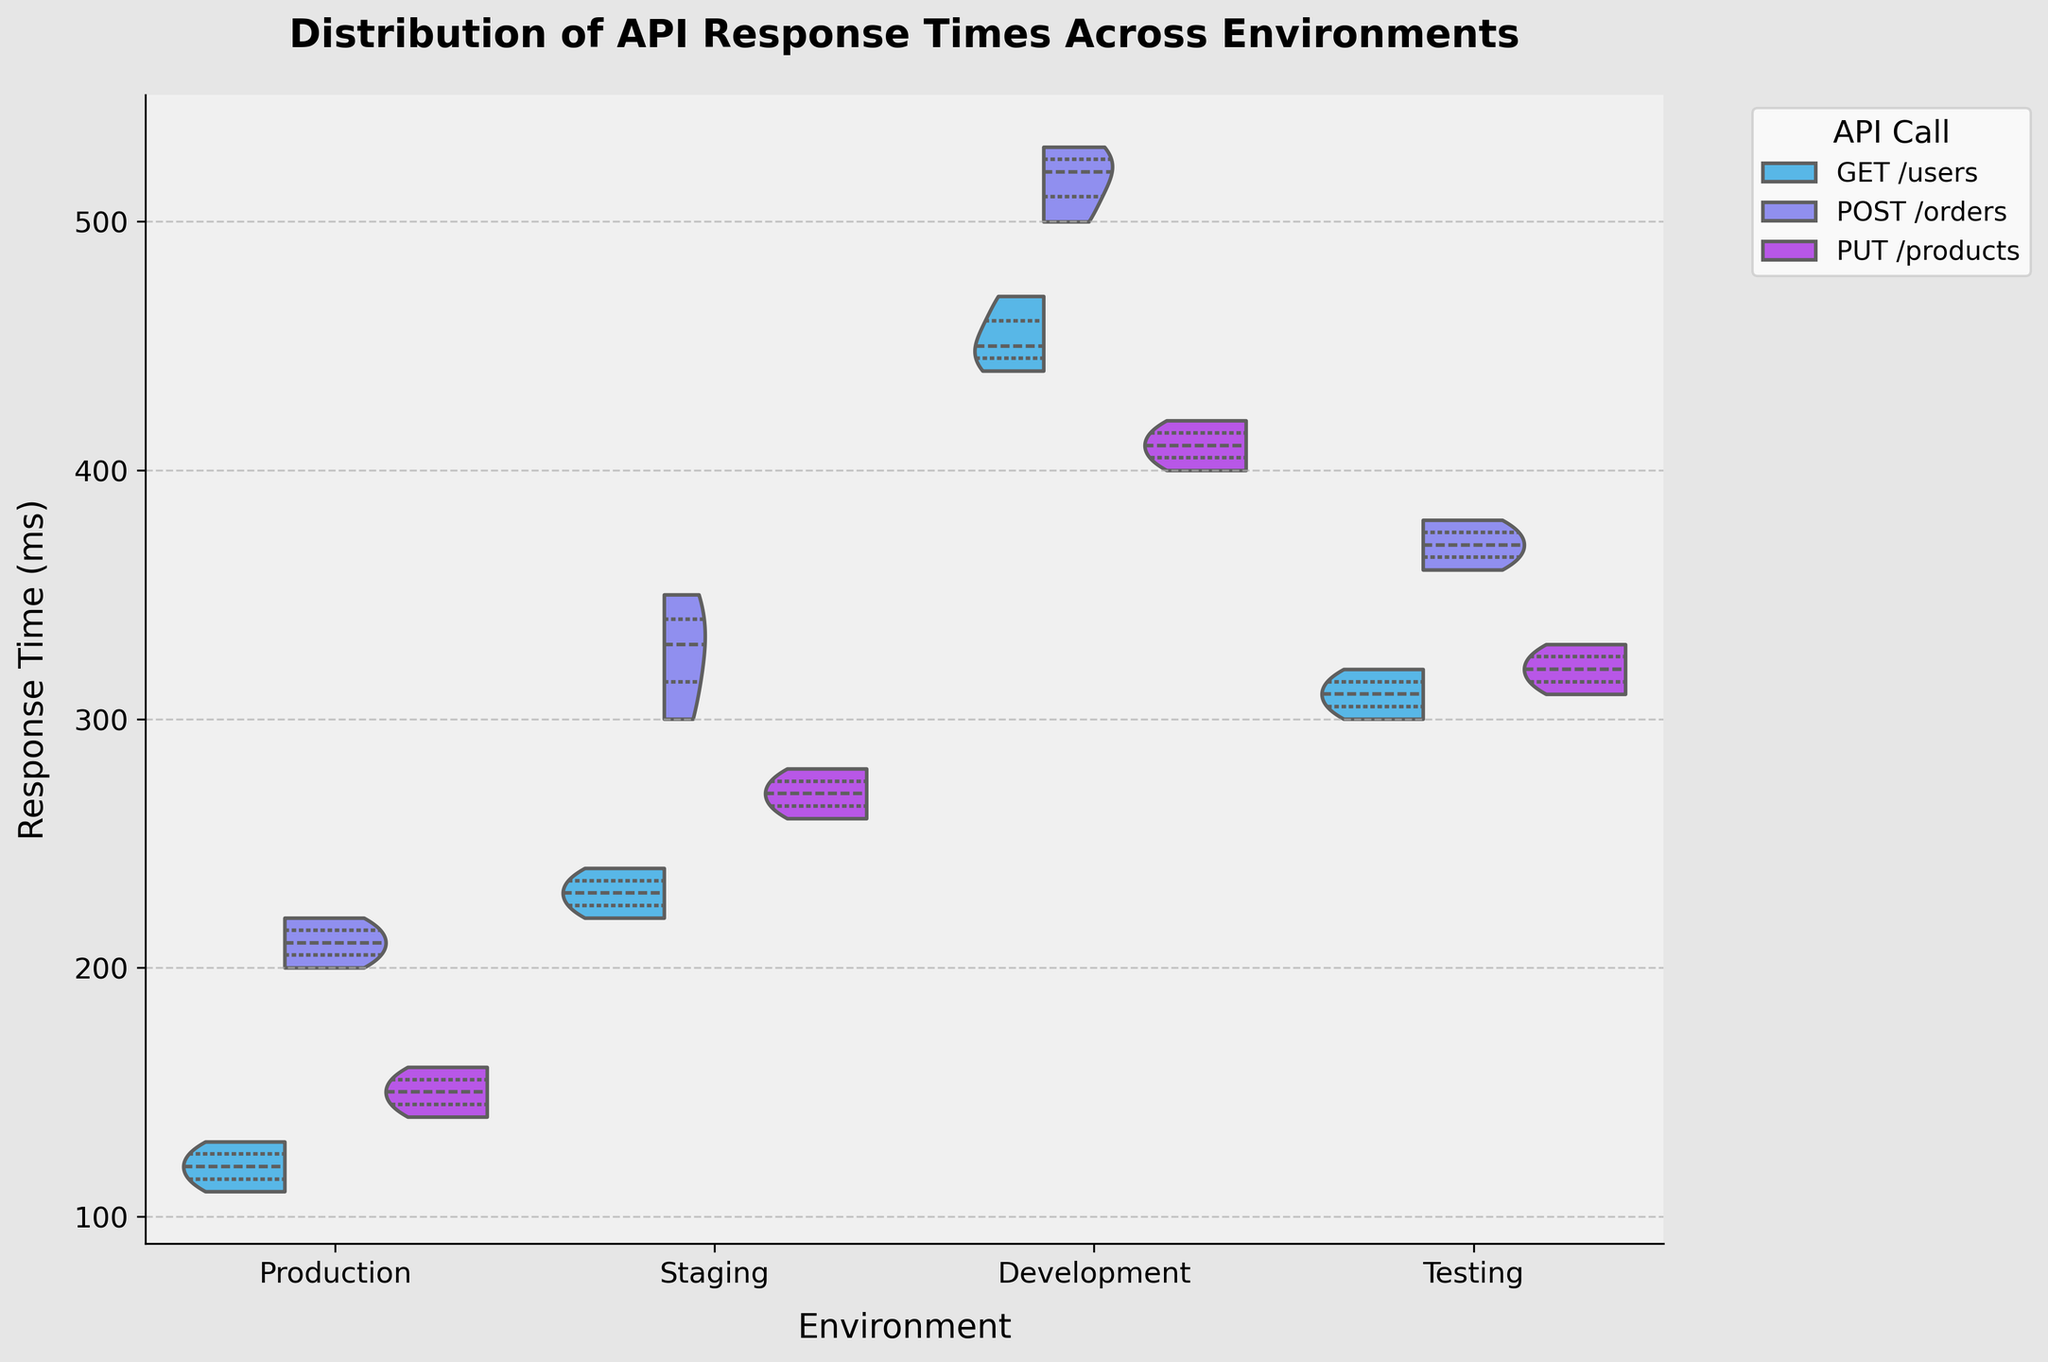What is the title of the violin plot? The title is located at the top center of the plot and should be clearly visible, indicating the main subject of the visualization.
Answer: Distribution of API Response Times Across Environments What are the labels of the x and y axes? The x-axis label is located under the horizontal axis, and the y-axis label is beside the vertical axis.
Answer: Environment, Response Time (ms) Which environment has the highest median response time for 'GET /users'? Look at the horizontal line in the center of the 'GET /users' violin for each environment and identify the highest point.
Answer: Development Are the response times for 'POST /orders' generally higher in Staging or Testing? Compare the spread and the median position (horizontal line inside the violins) of 'POST /orders' between Staging and Testing.
Answer: Staging Which API call has the largest spread of response times in Production? The spread can be identified by looking at the width of the violin plot. The larger the width, the greater the spread.
Answer: POST /orders What is the quartile distribution of response times for 'PUT /products' in the Testing environment? Each violin plot contains two internal horizontal lines representing the first and third quartiles. Identify these for the specified environment and API call.
Answer: Around 310 ms (1st quartile) and 330 ms (3rd quartile) Compare the median response times of 'GET /users' between the Production and Testing environments. Which one is higher and by how much? Look at the central line (median) in each respective violin plot and calculate the difference between them for the specified environments.
Answer: Testing by about 200 ms (310 ms vs. 110 ms) Is there any environment where the response times of 'PUT /products' have a noticeably different shape compared to the same API call in other environments? Observe the contour and width variations in the 'PUT /products' violins across different environments to identify any discrepancies.
Answer: Development (higher and more spread) In which environment is the response time for 'POST /orders' most consistent (least spread)? The consistency can be identified by observing the narrowest violin plot for the specified environment and API call.
Answer: Production Is there a significant overlap in response times between 'GET /users' and 'POST /orders' within the Staging environment? Look at the split violin plot for Staging and observe the shared region between 'GET /users' and 'POST /orders' to assess overlap.
Answer: Yes 